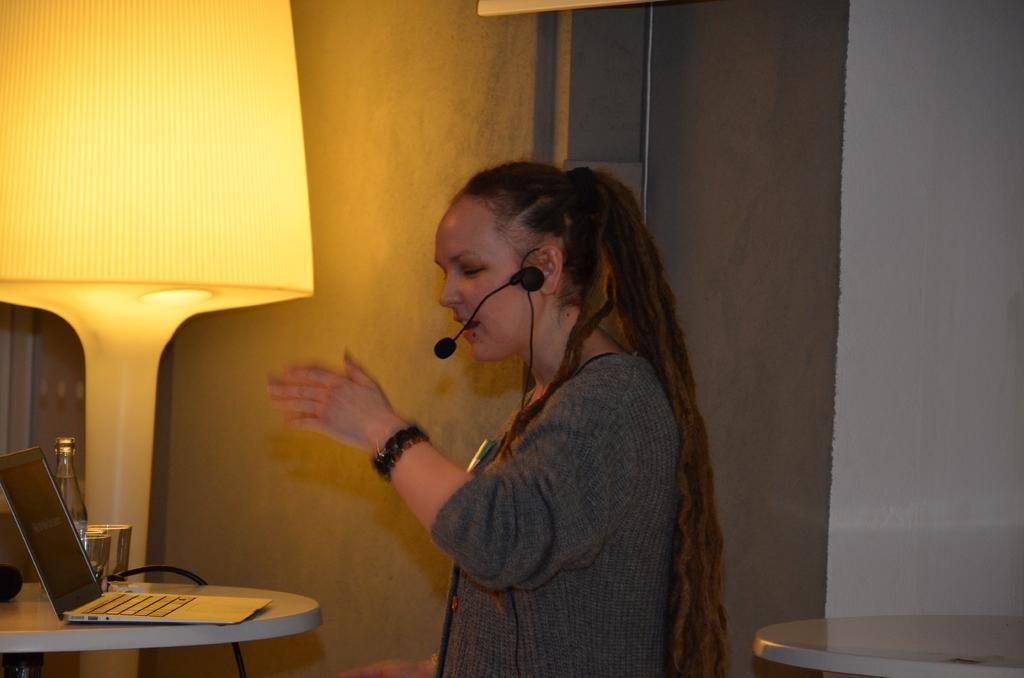How would you summarize this image in a sentence or two? In this picture we can see a woman, mic and in front of her we can see a laptop bottle, glasses on the table and in the background we can see the wall, lamp and some objects. 